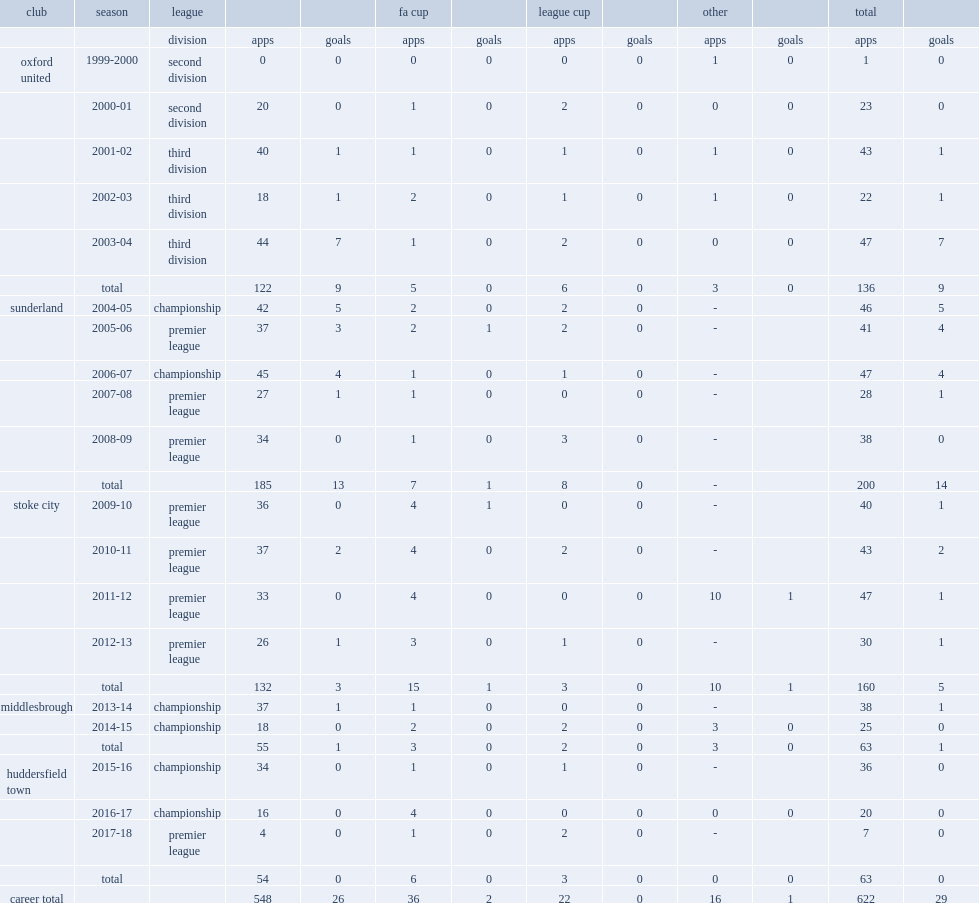Which club did dean whitehead play for in 2004-05? Sunderland. 